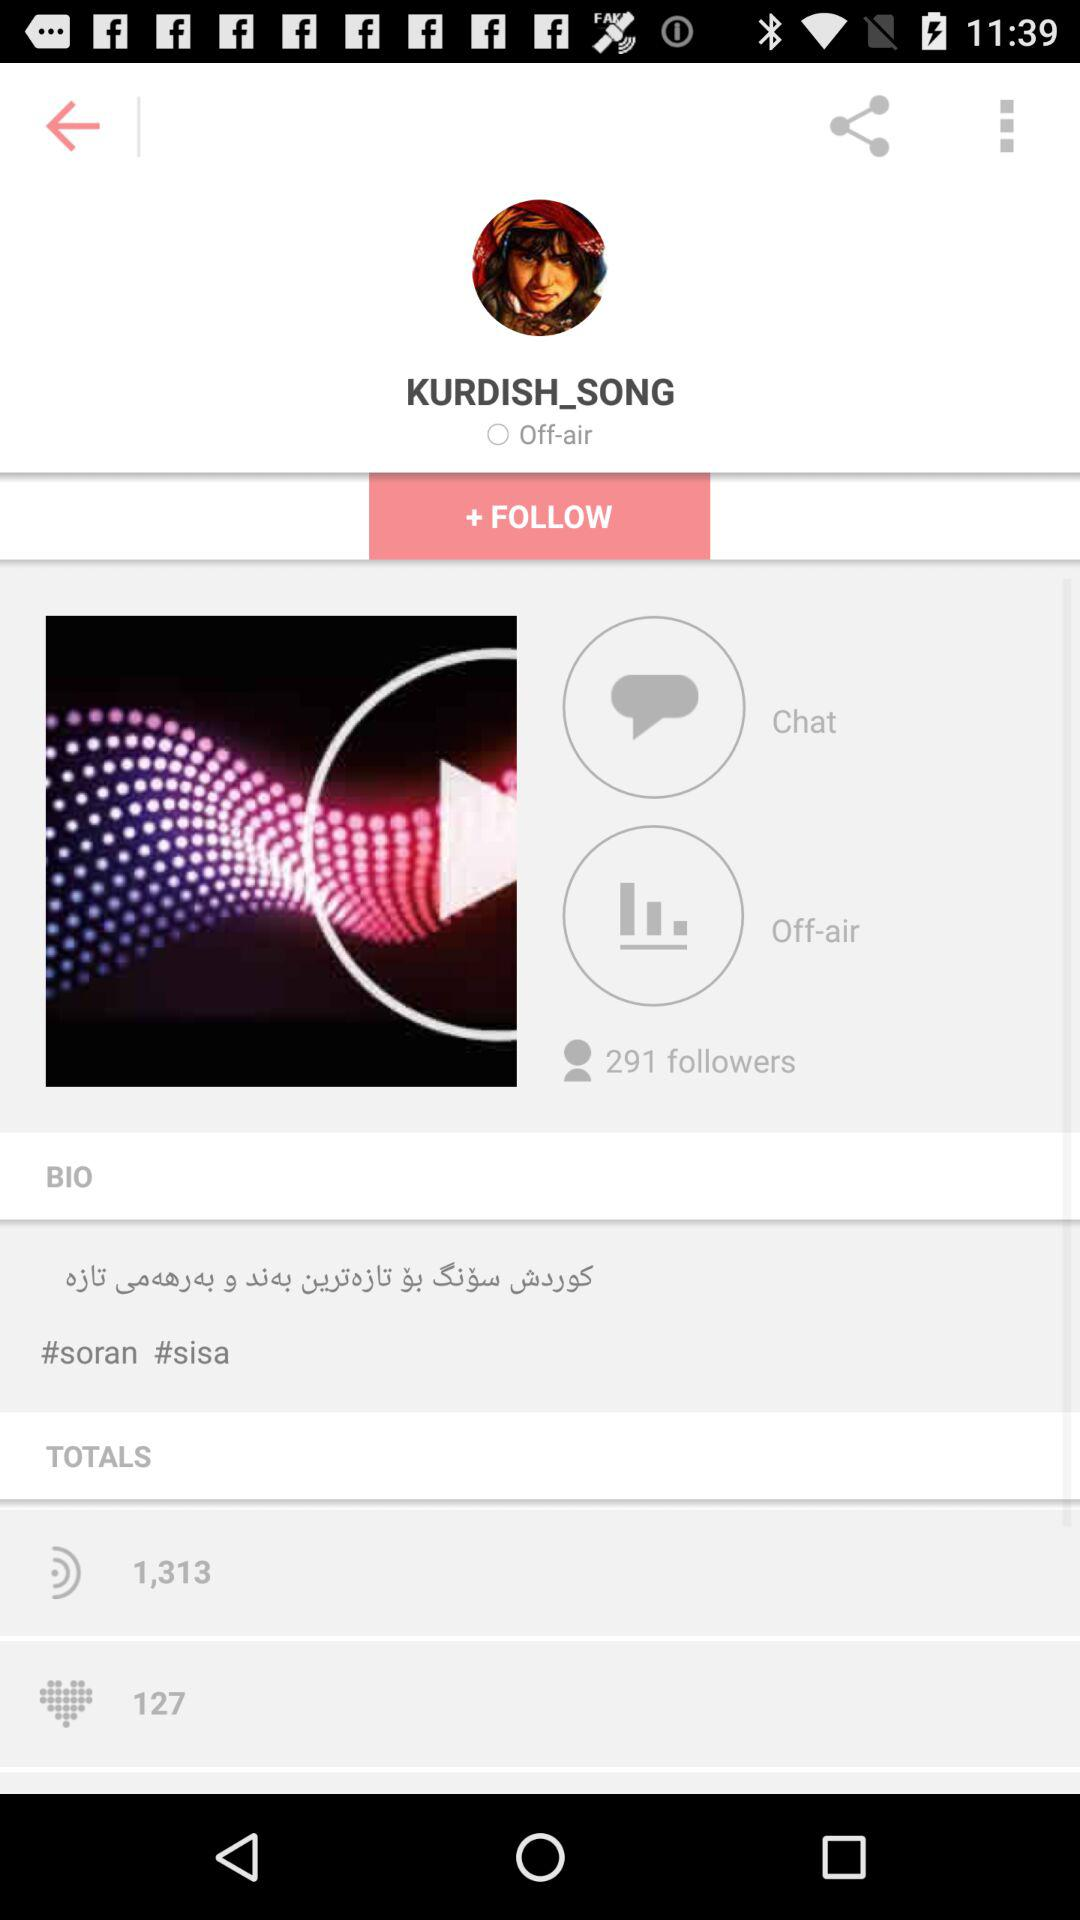How many likes are there? There are 127 likes. 